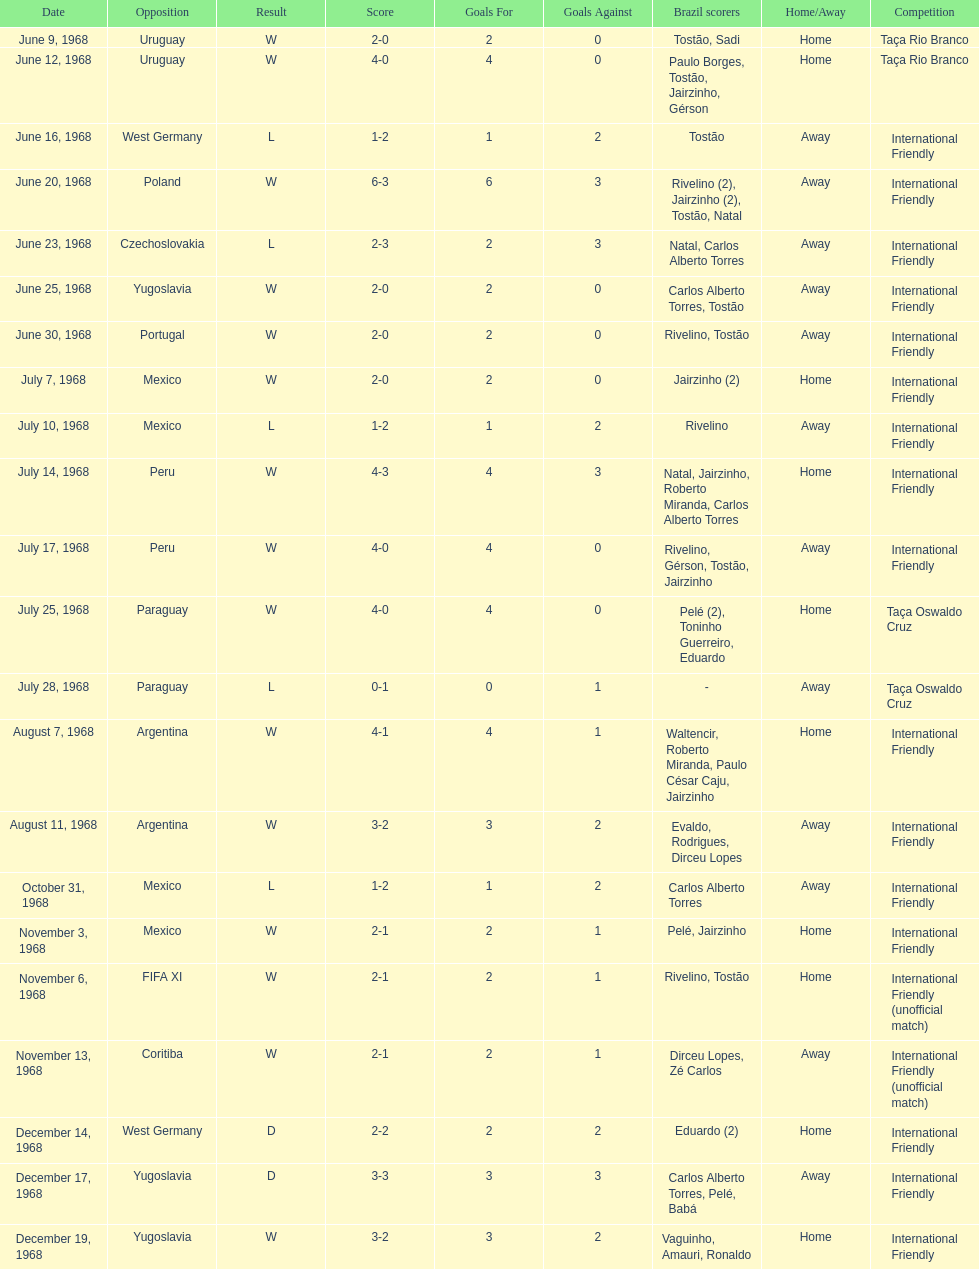Write the full table. {'header': ['Date', 'Opposition', 'Result', 'Score', 'Goals For', 'Goals Against', 'Brazil scorers', 'Home/Away', 'Competition'], 'rows': [['June 9, 1968', 'Uruguay', 'W', '2-0', '2', '0', 'Tostão, Sadi', 'Home', 'Taça Rio Branco'], ['June 12, 1968', 'Uruguay', 'W', '4-0', '4', '0', 'Paulo Borges, Tostão, Jairzinho, Gérson', 'Home', 'Taça Rio Branco'], ['June 16, 1968', 'West Germany', 'L', '1-2', '1', '2', 'Tostão', 'Away', 'International Friendly'], ['June 20, 1968', 'Poland', 'W', '6-3', '6', '3', 'Rivelino (2), Jairzinho (2), Tostão, Natal', 'Away', 'International Friendly'], ['June 23, 1968', 'Czechoslovakia', 'L', '2-3', '2', '3', 'Natal, Carlos Alberto Torres', 'Away', 'International Friendly'], ['June 25, 1968', 'Yugoslavia', 'W', '2-0', '2', '0', 'Carlos Alberto Torres, Tostão', 'Away', 'International Friendly'], ['June 30, 1968', 'Portugal', 'W', '2-0', '2', '0', 'Rivelino, Tostão', 'Away', 'International Friendly'], ['July 7, 1968', 'Mexico', 'W', '2-0', '2', '0', 'Jairzinho (2)', 'Home', 'International Friendly'], ['July 10, 1968', 'Mexico', 'L', '1-2', '1', '2', 'Rivelino', 'Away', 'International Friendly'], ['July 14, 1968', 'Peru', 'W', '4-3', '4', '3', 'Natal, Jairzinho, Roberto Miranda, Carlos Alberto Torres', 'Home', 'International Friendly'], ['July 17, 1968', 'Peru', 'W', '4-0', '4', '0', 'Rivelino, Gérson, Tostão, Jairzinho', 'Away', 'International Friendly'], ['July 25, 1968', 'Paraguay', 'W', '4-0', '4', '0', 'Pelé (2), Toninho Guerreiro, Eduardo', 'Home', 'Taça Oswaldo Cruz'], ['July 28, 1968', 'Paraguay', 'L', '0-1', '0', '1', '-', 'Away', 'Taça Oswaldo Cruz'], ['August 7, 1968', 'Argentina', 'W', '4-1', '4', '1', 'Waltencir, Roberto Miranda, Paulo César Caju, Jairzinho', 'Home', 'International Friendly'], ['August 11, 1968', 'Argentina', 'W', '3-2', '3', '2', 'Evaldo, Rodrigues, Dirceu Lopes', 'Away', 'International Friendly'], ['October 31, 1968', 'Mexico', 'L', '1-2', '1', '2', 'Carlos Alberto Torres', 'Away', 'International Friendly'], ['November 3, 1968', 'Mexico', 'W', '2-1', '2', '1', 'Pelé, Jairzinho', 'Home', 'International Friendly'], ['November 6, 1968', 'FIFA XI', 'W', '2-1', '2', '1', 'Rivelino, Tostão', 'Home', 'International Friendly (unofficial match)'], ['November 13, 1968', 'Coritiba', 'W', '2-1', '2', '1', 'Dirceu Lopes, Zé Carlos', 'Away', 'International Friendly (unofficial match)'], ['December 14, 1968', 'West Germany', 'D', '2-2', '2', '2', 'Eduardo (2)', 'Home', 'International Friendly'], ['December 17, 1968', 'Yugoslavia', 'D', '3-3', '3', '3', 'Carlos Alberto Torres, Pelé, Babá', 'Away', 'International Friendly'], ['December 19, 1968', 'Yugoslavia', 'W', '3-2', '3', '2', 'Vaguinho, Amauri, Ronaldo', 'Home', 'International Friendly']]} How many times did brazil play against argentina in the international friendly competition? 2. 